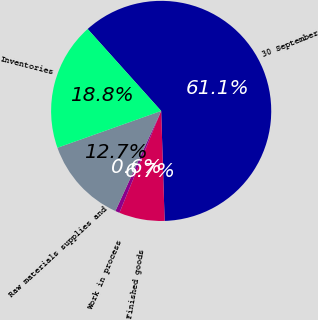Convert chart. <chart><loc_0><loc_0><loc_500><loc_500><pie_chart><fcel>30 September<fcel>Finished goods<fcel>Work in process<fcel>Raw materials supplies and<fcel>Inventories<nl><fcel>61.14%<fcel>6.69%<fcel>0.64%<fcel>12.74%<fcel>18.79%<nl></chart> 